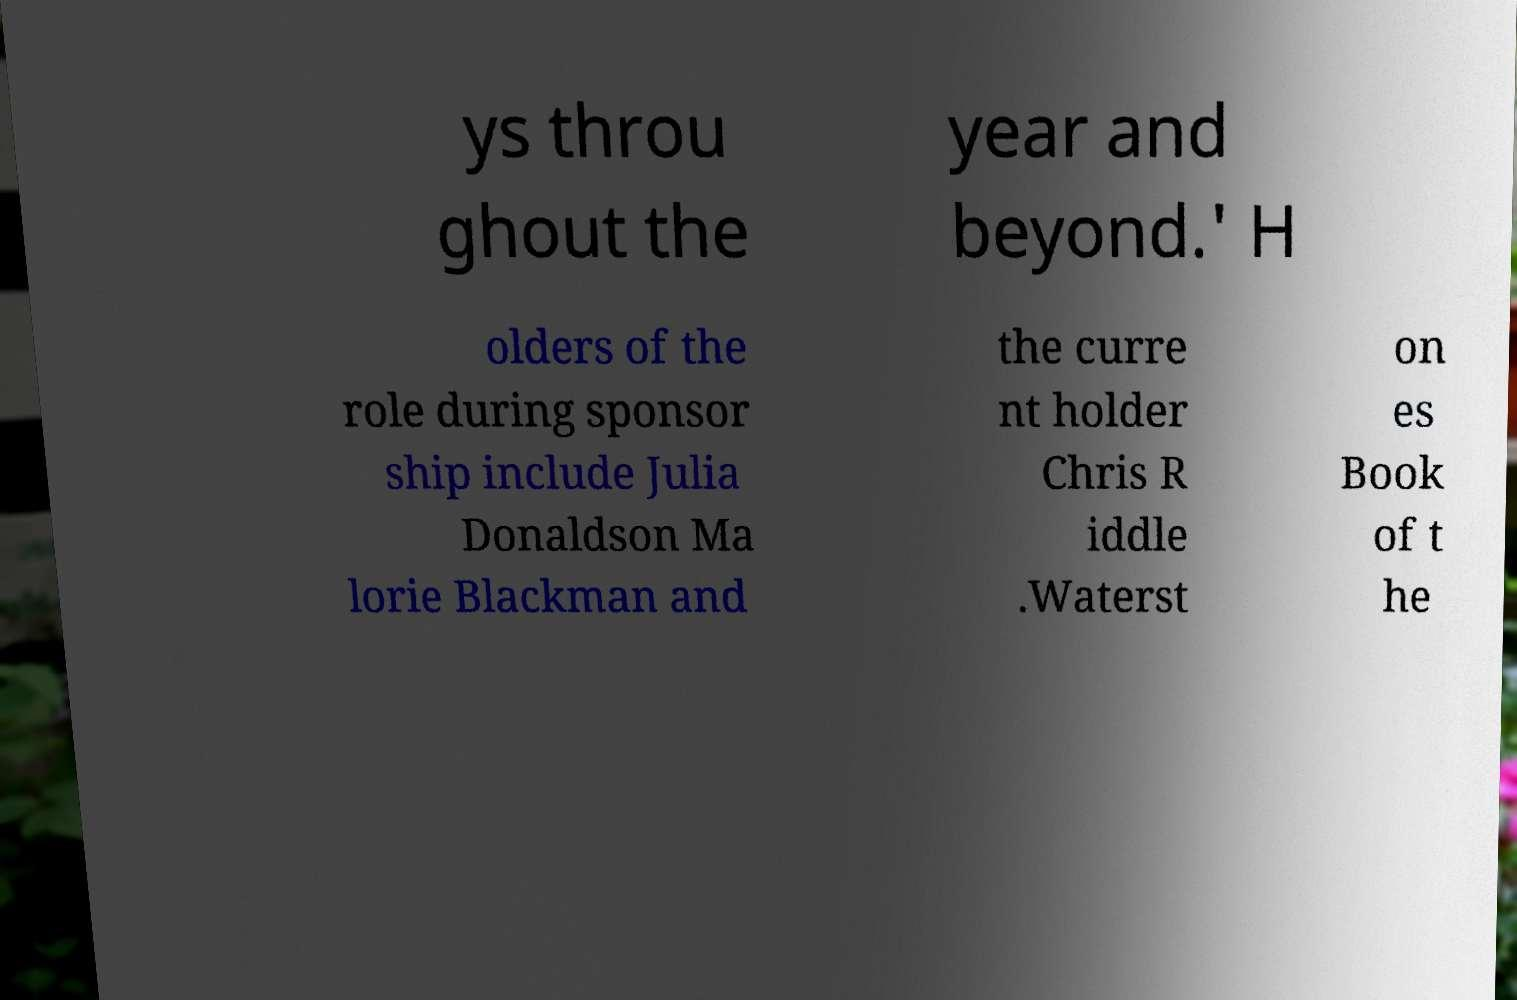Could you extract and type out the text from this image? ys throu ghout the year and beyond.' H olders of the role during sponsor ship include Julia Donaldson Ma lorie Blackman and the curre nt holder Chris R iddle .Waterst on es Book of t he 